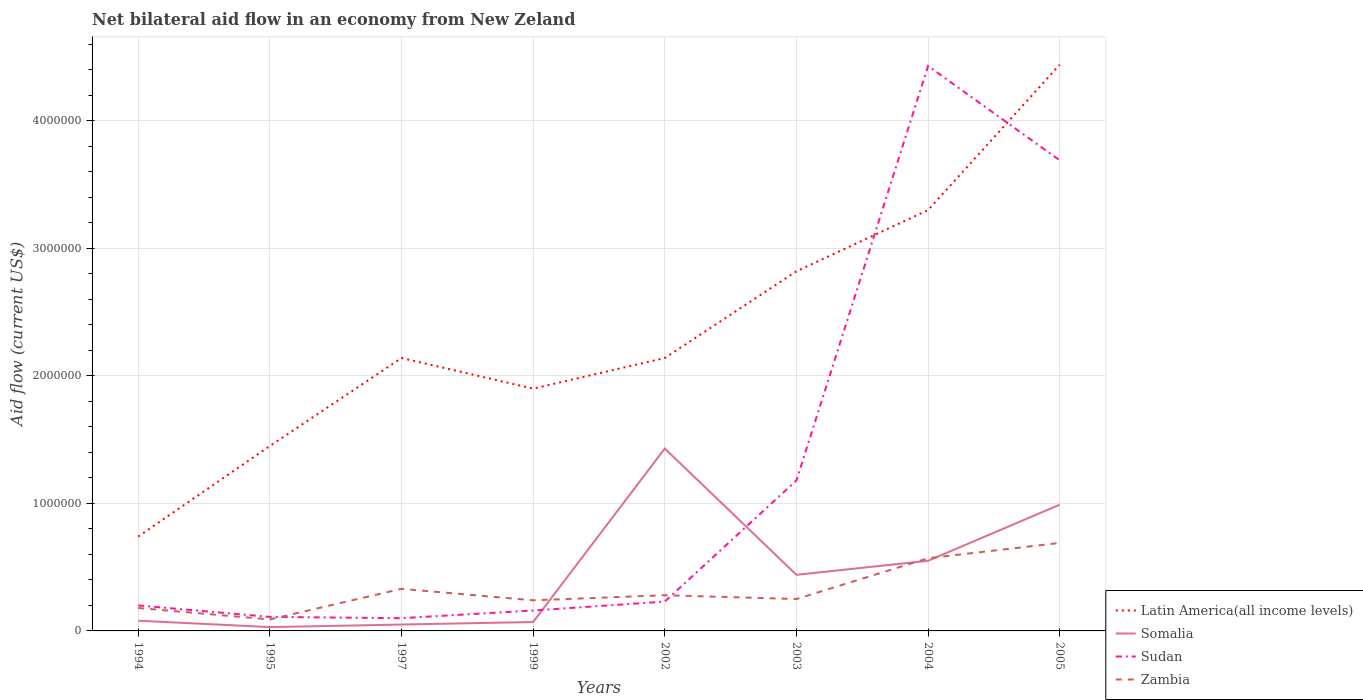How many different coloured lines are there?
Make the answer very short. 4. Does the line corresponding to Latin America(all income levels) intersect with the line corresponding to Zambia?
Keep it short and to the point. No. In which year was the net bilateral aid flow in Sudan maximum?
Provide a short and direct response. 1997. What is the difference between the highest and the second highest net bilateral aid flow in Sudan?
Provide a succinct answer. 4.33e+06. Is the net bilateral aid flow in Zambia strictly greater than the net bilateral aid flow in Latin America(all income levels) over the years?
Your answer should be very brief. Yes. How many lines are there?
Keep it short and to the point. 4. How many years are there in the graph?
Give a very brief answer. 8. Are the values on the major ticks of Y-axis written in scientific E-notation?
Give a very brief answer. No. Does the graph contain grids?
Offer a terse response. Yes. Where does the legend appear in the graph?
Give a very brief answer. Bottom right. How are the legend labels stacked?
Provide a succinct answer. Vertical. What is the title of the graph?
Make the answer very short. Net bilateral aid flow in an economy from New Zeland. What is the Aid flow (current US$) in Latin America(all income levels) in 1994?
Provide a succinct answer. 7.40e+05. What is the Aid flow (current US$) of Somalia in 1994?
Ensure brevity in your answer.  8.00e+04. What is the Aid flow (current US$) in Zambia in 1994?
Ensure brevity in your answer.  1.80e+05. What is the Aid flow (current US$) in Latin America(all income levels) in 1995?
Offer a terse response. 1.45e+06. What is the Aid flow (current US$) in Sudan in 1995?
Offer a very short reply. 1.10e+05. What is the Aid flow (current US$) in Zambia in 1995?
Your response must be concise. 9.00e+04. What is the Aid flow (current US$) of Latin America(all income levels) in 1997?
Keep it short and to the point. 2.14e+06. What is the Aid flow (current US$) of Zambia in 1997?
Give a very brief answer. 3.30e+05. What is the Aid flow (current US$) of Latin America(all income levels) in 1999?
Give a very brief answer. 1.90e+06. What is the Aid flow (current US$) in Somalia in 1999?
Give a very brief answer. 7.00e+04. What is the Aid flow (current US$) of Sudan in 1999?
Provide a short and direct response. 1.60e+05. What is the Aid flow (current US$) in Latin America(all income levels) in 2002?
Provide a short and direct response. 2.14e+06. What is the Aid flow (current US$) of Somalia in 2002?
Your answer should be compact. 1.43e+06. What is the Aid flow (current US$) of Sudan in 2002?
Your answer should be very brief. 2.30e+05. What is the Aid flow (current US$) of Zambia in 2002?
Give a very brief answer. 2.80e+05. What is the Aid flow (current US$) of Latin America(all income levels) in 2003?
Keep it short and to the point. 2.82e+06. What is the Aid flow (current US$) in Sudan in 2003?
Your answer should be very brief. 1.18e+06. What is the Aid flow (current US$) of Zambia in 2003?
Ensure brevity in your answer.  2.50e+05. What is the Aid flow (current US$) of Latin America(all income levels) in 2004?
Keep it short and to the point. 3.30e+06. What is the Aid flow (current US$) in Somalia in 2004?
Your response must be concise. 5.50e+05. What is the Aid flow (current US$) of Sudan in 2004?
Your answer should be compact. 4.43e+06. What is the Aid flow (current US$) in Zambia in 2004?
Your answer should be very brief. 5.70e+05. What is the Aid flow (current US$) in Latin America(all income levels) in 2005?
Ensure brevity in your answer.  4.44e+06. What is the Aid flow (current US$) of Somalia in 2005?
Make the answer very short. 9.90e+05. What is the Aid flow (current US$) in Sudan in 2005?
Your answer should be very brief. 3.69e+06. What is the Aid flow (current US$) in Zambia in 2005?
Ensure brevity in your answer.  6.90e+05. Across all years, what is the maximum Aid flow (current US$) of Latin America(all income levels)?
Your answer should be compact. 4.44e+06. Across all years, what is the maximum Aid flow (current US$) in Somalia?
Your response must be concise. 1.43e+06. Across all years, what is the maximum Aid flow (current US$) in Sudan?
Make the answer very short. 4.43e+06. Across all years, what is the maximum Aid flow (current US$) of Zambia?
Your answer should be compact. 6.90e+05. Across all years, what is the minimum Aid flow (current US$) of Latin America(all income levels)?
Ensure brevity in your answer.  7.40e+05. Across all years, what is the minimum Aid flow (current US$) in Sudan?
Provide a succinct answer. 1.00e+05. Across all years, what is the minimum Aid flow (current US$) in Zambia?
Your response must be concise. 9.00e+04. What is the total Aid flow (current US$) in Latin America(all income levels) in the graph?
Your answer should be very brief. 1.89e+07. What is the total Aid flow (current US$) in Somalia in the graph?
Ensure brevity in your answer.  3.64e+06. What is the total Aid flow (current US$) of Sudan in the graph?
Your answer should be very brief. 1.01e+07. What is the total Aid flow (current US$) of Zambia in the graph?
Provide a short and direct response. 2.63e+06. What is the difference between the Aid flow (current US$) in Latin America(all income levels) in 1994 and that in 1995?
Your response must be concise. -7.10e+05. What is the difference between the Aid flow (current US$) in Somalia in 1994 and that in 1995?
Provide a short and direct response. 5.00e+04. What is the difference between the Aid flow (current US$) in Sudan in 1994 and that in 1995?
Your answer should be very brief. 9.00e+04. What is the difference between the Aid flow (current US$) in Latin America(all income levels) in 1994 and that in 1997?
Provide a short and direct response. -1.40e+06. What is the difference between the Aid flow (current US$) in Sudan in 1994 and that in 1997?
Provide a short and direct response. 1.00e+05. What is the difference between the Aid flow (current US$) in Latin America(all income levels) in 1994 and that in 1999?
Give a very brief answer. -1.16e+06. What is the difference between the Aid flow (current US$) of Latin America(all income levels) in 1994 and that in 2002?
Keep it short and to the point. -1.40e+06. What is the difference between the Aid flow (current US$) of Somalia in 1994 and that in 2002?
Make the answer very short. -1.35e+06. What is the difference between the Aid flow (current US$) in Latin America(all income levels) in 1994 and that in 2003?
Keep it short and to the point. -2.08e+06. What is the difference between the Aid flow (current US$) of Somalia in 1994 and that in 2003?
Your answer should be very brief. -3.60e+05. What is the difference between the Aid flow (current US$) of Sudan in 1994 and that in 2003?
Ensure brevity in your answer.  -9.80e+05. What is the difference between the Aid flow (current US$) in Zambia in 1994 and that in 2003?
Ensure brevity in your answer.  -7.00e+04. What is the difference between the Aid flow (current US$) of Latin America(all income levels) in 1994 and that in 2004?
Your answer should be compact. -2.56e+06. What is the difference between the Aid flow (current US$) of Somalia in 1994 and that in 2004?
Your answer should be very brief. -4.70e+05. What is the difference between the Aid flow (current US$) in Sudan in 1994 and that in 2004?
Provide a short and direct response. -4.23e+06. What is the difference between the Aid flow (current US$) in Zambia in 1994 and that in 2004?
Make the answer very short. -3.90e+05. What is the difference between the Aid flow (current US$) in Latin America(all income levels) in 1994 and that in 2005?
Offer a very short reply. -3.70e+06. What is the difference between the Aid flow (current US$) in Somalia in 1994 and that in 2005?
Provide a short and direct response. -9.10e+05. What is the difference between the Aid flow (current US$) of Sudan in 1994 and that in 2005?
Make the answer very short. -3.49e+06. What is the difference between the Aid flow (current US$) of Zambia in 1994 and that in 2005?
Provide a short and direct response. -5.10e+05. What is the difference between the Aid flow (current US$) in Latin America(all income levels) in 1995 and that in 1997?
Your answer should be very brief. -6.90e+05. What is the difference between the Aid flow (current US$) in Somalia in 1995 and that in 1997?
Keep it short and to the point. -2.00e+04. What is the difference between the Aid flow (current US$) in Sudan in 1995 and that in 1997?
Give a very brief answer. 10000. What is the difference between the Aid flow (current US$) of Latin America(all income levels) in 1995 and that in 1999?
Make the answer very short. -4.50e+05. What is the difference between the Aid flow (current US$) in Zambia in 1995 and that in 1999?
Ensure brevity in your answer.  -1.50e+05. What is the difference between the Aid flow (current US$) of Latin America(all income levels) in 1995 and that in 2002?
Make the answer very short. -6.90e+05. What is the difference between the Aid flow (current US$) of Somalia in 1995 and that in 2002?
Keep it short and to the point. -1.40e+06. What is the difference between the Aid flow (current US$) in Sudan in 1995 and that in 2002?
Your answer should be very brief. -1.20e+05. What is the difference between the Aid flow (current US$) of Latin America(all income levels) in 1995 and that in 2003?
Offer a terse response. -1.37e+06. What is the difference between the Aid flow (current US$) of Somalia in 1995 and that in 2003?
Your answer should be very brief. -4.10e+05. What is the difference between the Aid flow (current US$) in Sudan in 1995 and that in 2003?
Keep it short and to the point. -1.07e+06. What is the difference between the Aid flow (current US$) in Zambia in 1995 and that in 2003?
Make the answer very short. -1.60e+05. What is the difference between the Aid flow (current US$) of Latin America(all income levels) in 1995 and that in 2004?
Make the answer very short. -1.85e+06. What is the difference between the Aid flow (current US$) of Somalia in 1995 and that in 2004?
Offer a very short reply. -5.20e+05. What is the difference between the Aid flow (current US$) in Sudan in 1995 and that in 2004?
Your answer should be compact. -4.32e+06. What is the difference between the Aid flow (current US$) of Zambia in 1995 and that in 2004?
Your response must be concise. -4.80e+05. What is the difference between the Aid flow (current US$) of Latin America(all income levels) in 1995 and that in 2005?
Provide a succinct answer. -2.99e+06. What is the difference between the Aid flow (current US$) of Somalia in 1995 and that in 2005?
Your response must be concise. -9.60e+05. What is the difference between the Aid flow (current US$) of Sudan in 1995 and that in 2005?
Keep it short and to the point. -3.58e+06. What is the difference between the Aid flow (current US$) of Zambia in 1995 and that in 2005?
Your response must be concise. -6.00e+05. What is the difference between the Aid flow (current US$) in Latin America(all income levels) in 1997 and that in 1999?
Offer a very short reply. 2.40e+05. What is the difference between the Aid flow (current US$) of Somalia in 1997 and that in 1999?
Make the answer very short. -2.00e+04. What is the difference between the Aid flow (current US$) of Sudan in 1997 and that in 1999?
Ensure brevity in your answer.  -6.00e+04. What is the difference between the Aid flow (current US$) of Latin America(all income levels) in 1997 and that in 2002?
Your response must be concise. 0. What is the difference between the Aid flow (current US$) of Somalia in 1997 and that in 2002?
Give a very brief answer. -1.38e+06. What is the difference between the Aid flow (current US$) in Latin America(all income levels) in 1997 and that in 2003?
Keep it short and to the point. -6.80e+05. What is the difference between the Aid flow (current US$) of Somalia in 1997 and that in 2003?
Your answer should be very brief. -3.90e+05. What is the difference between the Aid flow (current US$) in Sudan in 1997 and that in 2003?
Offer a very short reply. -1.08e+06. What is the difference between the Aid flow (current US$) of Zambia in 1997 and that in 2003?
Keep it short and to the point. 8.00e+04. What is the difference between the Aid flow (current US$) of Latin America(all income levels) in 1997 and that in 2004?
Provide a short and direct response. -1.16e+06. What is the difference between the Aid flow (current US$) of Somalia in 1997 and that in 2004?
Keep it short and to the point. -5.00e+05. What is the difference between the Aid flow (current US$) of Sudan in 1997 and that in 2004?
Your answer should be very brief. -4.33e+06. What is the difference between the Aid flow (current US$) in Zambia in 1997 and that in 2004?
Make the answer very short. -2.40e+05. What is the difference between the Aid flow (current US$) in Latin America(all income levels) in 1997 and that in 2005?
Give a very brief answer. -2.30e+06. What is the difference between the Aid flow (current US$) in Somalia in 1997 and that in 2005?
Provide a succinct answer. -9.40e+05. What is the difference between the Aid flow (current US$) of Sudan in 1997 and that in 2005?
Provide a short and direct response. -3.59e+06. What is the difference between the Aid flow (current US$) of Zambia in 1997 and that in 2005?
Make the answer very short. -3.60e+05. What is the difference between the Aid flow (current US$) of Somalia in 1999 and that in 2002?
Give a very brief answer. -1.36e+06. What is the difference between the Aid flow (current US$) in Sudan in 1999 and that in 2002?
Keep it short and to the point. -7.00e+04. What is the difference between the Aid flow (current US$) in Zambia in 1999 and that in 2002?
Give a very brief answer. -4.00e+04. What is the difference between the Aid flow (current US$) in Latin America(all income levels) in 1999 and that in 2003?
Provide a succinct answer. -9.20e+05. What is the difference between the Aid flow (current US$) of Somalia in 1999 and that in 2003?
Offer a terse response. -3.70e+05. What is the difference between the Aid flow (current US$) of Sudan in 1999 and that in 2003?
Ensure brevity in your answer.  -1.02e+06. What is the difference between the Aid flow (current US$) in Zambia in 1999 and that in 2003?
Give a very brief answer. -10000. What is the difference between the Aid flow (current US$) in Latin America(all income levels) in 1999 and that in 2004?
Keep it short and to the point. -1.40e+06. What is the difference between the Aid flow (current US$) of Somalia in 1999 and that in 2004?
Provide a succinct answer. -4.80e+05. What is the difference between the Aid flow (current US$) of Sudan in 1999 and that in 2004?
Make the answer very short. -4.27e+06. What is the difference between the Aid flow (current US$) of Zambia in 1999 and that in 2004?
Your response must be concise. -3.30e+05. What is the difference between the Aid flow (current US$) of Latin America(all income levels) in 1999 and that in 2005?
Ensure brevity in your answer.  -2.54e+06. What is the difference between the Aid flow (current US$) in Somalia in 1999 and that in 2005?
Offer a terse response. -9.20e+05. What is the difference between the Aid flow (current US$) of Sudan in 1999 and that in 2005?
Your response must be concise. -3.53e+06. What is the difference between the Aid flow (current US$) of Zambia in 1999 and that in 2005?
Your answer should be compact. -4.50e+05. What is the difference between the Aid flow (current US$) in Latin America(all income levels) in 2002 and that in 2003?
Your answer should be compact. -6.80e+05. What is the difference between the Aid flow (current US$) of Somalia in 2002 and that in 2003?
Make the answer very short. 9.90e+05. What is the difference between the Aid flow (current US$) in Sudan in 2002 and that in 2003?
Give a very brief answer. -9.50e+05. What is the difference between the Aid flow (current US$) in Latin America(all income levels) in 2002 and that in 2004?
Make the answer very short. -1.16e+06. What is the difference between the Aid flow (current US$) in Somalia in 2002 and that in 2004?
Offer a very short reply. 8.80e+05. What is the difference between the Aid flow (current US$) in Sudan in 2002 and that in 2004?
Provide a succinct answer. -4.20e+06. What is the difference between the Aid flow (current US$) in Zambia in 2002 and that in 2004?
Give a very brief answer. -2.90e+05. What is the difference between the Aid flow (current US$) in Latin America(all income levels) in 2002 and that in 2005?
Keep it short and to the point. -2.30e+06. What is the difference between the Aid flow (current US$) in Sudan in 2002 and that in 2005?
Your answer should be very brief. -3.46e+06. What is the difference between the Aid flow (current US$) of Zambia in 2002 and that in 2005?
Offer a very short reply. -4.10e+05. What is the difference between the Aid flow (current US$) in Latin America(all income levels) in 2003 and that in 2004?
Your answer should be compact. -4.80e+05. What is the difference between the Aid flow (current US$) in Sudan in 2003 and that in 2004?
Give a very brief answer. -3.25e+06. What is the difference between the Aid flow (current US$) in Zambia in 2003 and that in 2004?
Give a very brief answer. -3.20e+05. What is the difference between the Aid flow (current US$) in Latin America(all income levels) in 2003 and that in 2005?
Make the answer very short. -1.62e+06. What is the difference between the Aid flow (current US$) of Somalia in 2003 and that in 2005?
Provide a short and direct response. -5.50e+05. What is the difference between the Aid flow (current US$) in Sudan in 2003 and that in 2005?
Provide a succinct answer. -2.51e+06. What is the difference between the Aid flow (current US$) of Zambia in 2003 and that in 2005?
Make the answer very short. -4.40e+05. What is the difference between the Aid flow (current US$) in Latin America(all income levels) in 2004 and that in 2005?
Offer a very short reply. -1.14e+06. What is the difference between the Aid flow (current US$) of Somalia in 2004 and that in 2005?
Offer a very short reply. -4.40e+05. What is the difference between the Aid flow (current US$) of Sudan in 2004 and that in 2005?
Provide a short and direct response. 7.40e+05. What is the difference between the Aid flow (current US$) of Latin America(all income levels) in 1994 and the Aid flow (current US$) of Somalia in 1995?
Ensure brevity in your answer.  7.10e+05. What is the difference between the Aid flow (current US$) in Latin America(all income levels) in 1994 and the Aid flow (current US$) in Sudan in 1995?
Make the answer very short. 6.30e+05. What is the difference between the Aid flow (current US$) in Latin America(all income levels) in 1994 and the Aid flow (current US$) in Zambia in 1995?
Your answer should be very brief. 6.50e+05. What is the difference between the Aid flow (current US$) in Sudan in 1994 and the Aid flow (current US$) in Zambia in 1995?
Provide a short and direct response. 1.10e+05. What is the difference between the Aid flow (current US$) in Latin America(all income levels) in 1994 and the Aid flow (current US$) in Somalia in 1997?
Make the answer very short. 6.90e+05. What is the difference between the Aid flow (current US$) of Latin America(all income levels) in 1994 and the Aid flow (current US$) of Sudan in 1997?
Ensure brevity in your answer.  6.40e+05. What is the difference between the Aid flow (current US$) in Latin America(all income levels) in 1994 and the Aid flow (current US$) in Zambia in 1997?
Offer a very short reply. 4.10e+05. What is the difference between the Aid flow (current US$) of Latin America(all income levels) in 1994 and the Aid flow (current US$) of Somalia in 1999?
Ensure brevity in your answer.  6.70e+05. What is the difference between the Aid flow (current US$) in Latin America(all income levels) in 1994 and the Aid flow (current US$) in Sudan in 1999?
Offer a very short reply. 5.80e+05. What is the difference between the Aid flow (current US$) in Latin America(all income levels) in 1994 and the Aid flow (current US$) in Zambia in 1999?
Your response must be concise. 5.00e+05. What is the difference between the Aid flow (current US$) of Somalia in 1994 and the Aid flow (current US$) of Zambia in 1999?
Your answer should be compact. -1.60e+05. What is the difference between the Aid flow (current US$) in Sudan in 1994 and the Aid flow (current US$) in Zambia in 1999?
Provide a short and direct response. -4.00e+04. What is the difference between the Aid flow (current US$) in Latin America(all income levels) in 1994 and the Aid flow (current US$) in Somalia in 2002?
Offer a terse response. -6.90e+05. What is the difference between the Aid flow (current US$) of Latin America(all income levels) in 1994 and the Aid flow (current US$) of Sudan in 2002?
Give a very brief answer. 5.10e+05. What is the difference between the Aid flow (current US$) in Latin America(all income levels) in 1994 and the Aid flow (current US$) in Zambia in 2002?
Ensure brevity in your answer.  4.60e+05. What is the difference between the Aid flow (current US$) of Somalia in 1994 and the Aid flow (current US$) of Sudan in 2002?
Provide a succinct answer. -1.50e+05. What is the difference between the Aid flow (current US$) in Sudan in 1994 and the Aid flow (current US$) in Zambia in 2002?
Ensure brevity in your answer.  -8.00e+04. What is the difference between the Aid flow (current US$) in Latin America(all income levels) in 1994 and the Aid flow (current US$) in Sudan in 2003?
Offer a terse response. -4.40e+05. What is the difference between the Aid flow (current US$) of Somalia in 1994 and the Aid flow (current US$) of Sudan in 2003?
Your answer should be very brief. -1.10e+06. What is the difference between the Aid flow (current US$) of Somalia in 1994 and the Aid flow (current US$) of Zambia in 2003?
Ensure brevity in your answer.  -1.70e+05. What is the difference between the Aid flow (current US$) in Sudan in 1994 and the Aid flow (current US$) in Zambia in 2003?
Make the answer very short. -5.00e+04. What is the difference between the Aid flow (current US$) in Latin America(all income levels) in 1994 and the Aid flow (current US$) in Sudan in 2004?
Provide a succinct answer. -3.69e+06. What is the difference between the Aid flow (current US$) of Latin America(all income levels) in 1994 and the Aid flow (current US$) of Zambia in 2004?
Make the answer very short. 1.70e+05. What is the difference between the Aid flow (current US$) of Somalia in 1994 and the Aid flow (current US$) of Sudan in 2004?
Ensure brevity in your answer.  -4.35e+06. What is the difference between the Aid flow (current US$) of Somalia in 1994 and the Aid flow (current US$) of Zambia in 2004?
Your answer should be compact. -4.90e+05. What is the difference between the Aid flow (current US$) of Sudan in 1994 and the Aid flow (current US$) of Zambia in 2004?
Make the answer very short. -3.70e+05. What is the difference between the Aid flow (current US$) in Latin America(all income levels) in 1994 and the Aid flow (current US$) in Somalia in 2005?
Keep it short and to the point. -2.50e+05. What is the difference between the Aid flow (current US$) in Latin America(all income levels) in 1994 and the Aid flow (current US$) in Sudan in 2005?
Ensure brevity in your answer.  -2.95e+06. What is the difference between the Aid flow (current US$) of Latin America(all income levels) in 1994 and the Aid flow (current US$) of Zambia in 2005?
Give a very brief answer. 5.00e+04. What is the difference between the Aid flow (current US$) in Somalia in 1994 and the Aid flow (current US$) in Sudan in 2005?
Provide a short and direct response. -3.61e+06. What is the difference between the Aid flow (current US$) of Somalia in 1994 and the Aid flow (current US$) of Zambia in 2005?
Provide a short and direct response. -6.10e+05. What is the difference between the Aid flow (current US$) in Sudan in 1994 and the Aid flow (current US$) in Zambia in 2005?
Provide a succinct answer. -4.90e+05. What is the difference between the Aid flow (current US$) of Latin America(all income levels) in 1995 and the Aid flow (current US$) of Somalia in 1997?
Offer a very short reply. 1.40e+06. What is the difference between the Aid flow (current US$) in Latin America(all income levels) in 1995 and the Aid flow (current US$) in Sudan in 1997?
Your answer should be compact. 1.35e+06. What is the difference between the Aid flow (current US$) in Latin America(all income levels) in 1995 and the Aid flow (current US$) in Zambia in 1997?
Your answer should be compact. 1.12e+06. What is the difference between the Aid flow (current US$) of Somalia in 1995 and the Aid flow (current US$) of Sudan in 1997?
Give a very brief answer. -7.00e+04. What is the difference between the Aid flow (current US$) in Somalia in 1995 and the Aid flow (current US$) in Zambia in 1997?
Your response must be concise. -3.00e+05. What is the difference between the Aid flow (current US$) in Latin America(all income levels) in 1995 and the Aid flow (current US$) in Somalia in 1999?
Make the answer very short. 1.38e+06. What is the difference between the Aid flow (current US$) of Latin America(all income levels) in 1995 and the Aid flow (current US$) of Sudan in 1999?
Offer a terse response. 1.29e+06. What is the difference between the Aid flow (current US$) in Latin America(all income levels) in 1995 and the Aid flow (current US$) in Zambia in 1999?
Ensure brevity in your answer.  1.21e+06. What is the difference between the Aid flow (current US$) of Latin America(all income levels) in 1995 and the Aid flow (current US$) of Somalia in 2002?
Your answer should be compact. 2.00e+04. What is the difference between the Aid flow (current US$) of Latin America(all income levels) in 1995 and the Aid flow (current US$) of Sudan in 2002?
Offer a terse response. 1.22e+06. What is the difference between the Aid flow (current US$) in Latin America(all income levels) in 1995 and the Aid flow (current US$) in Zambia in 2002?
Give a very brief answer. 1.17e+06. What is the difference between the Aid flow (current US$) of Latin America(all income levels) in 1995 and the Aid flow (current US$) of Somalia in 2003?
Keep it short and to the point. 1.01e+06. What is the difference between the Aid flow (current US$) in Latin America(all income levels) in 1995 and the Aid flow (current US$) in Zambia in 2003?
Provide a succinct answer. 1.20e+06. What is the difference between the Aid flow (current US$) of Somalia in 1995 and the Aid flow (current US$) of Sudan in 2003?
Your answer should be compact. -1.15e+06. What is the difference between the Aid flow (current US$) in Somalia in 1995 and the Aid flow (current US$) in Zambia in 2003?
Offer a very short reply. -2.20e+05. What is the difference between the Aid flow (current US$) in Latin America(all income levels) in 1995 and the Aid flow (current US$) in Somalia in 2004?
Offer a very short reply. 9.00e+05. What is the difference between the Aid flow (current US$) of Latin America(all income levels) in 1995 and the Aid flow (current US$) of Sudan in 2004?
Provide a short and direct response. -2.98e+06. What is the difference between the Aid flow (current US$) in Latin America(all income levels) in 1995 and the Aid flow (current US$) in Zambia in 2004?
Provide a succinct answer. 8.80e+05. What is the difference between the Aid flow (current US$) in Somalia in 1995 and the Aid flow (current US$) in Sudan in 2004?
Your answer should be compact. -4.40e+06. What is the difference between the Aid flow (current US$) of Somalia in 1995 and the Aid flow (current US$) of Zambia in 2004?
Provide a succinct answer. -5.40e+05. What is the difference between the Aid flow (current US$) in Sudan in 1995 and the Aid flow (current US$) in Zambia in 2004?
Your answer should be compact. -4.60e+05. What is the difference between the Aid flow (current US$) of Latin America(all income levels) in 1995 and the Aid flow (current US$) of Sudan in 2005?
Keep it short and to the point. -2.24e+06. What is the difference between the Aid flow (current US$) of Latin America(all income levels) in 1995 and the Aid flow (current US$) of Zambia in 2005?
Keep it short and to the point. 7.60e+05. What is the difference between the Aid flow (current US$) of Somalia in 1995 and the Aid flow (current US$) of Sudan in 2005?
Provide a succinct answer. -3.66e+06. What is the difference between the Aid flow (current US$) of Somalia in 1995 and the Aid flow (current US$) of Zambia in 2005?
Offer a very short reply. -6.60e+05. What is the difference between the Aid flow (current US$) in Sudan in 1995 and the Aid flow (current US$) in Zambia in 2005?
Offer a very short reply. -5.80e+05. What is the difference between the Aid flow (current US$) in Latin America(all income levels) in 1997 and the Aid flow (current US$) in Somalia in 1999?
Provide a succinct answer. 2.07e+06. What is the difference between the Aid flow (current US$) in Latin America(all income levels) in 1997 and the Aid flow (current US$) in Sudan in 1999?
Make the answer very short. 1.98e+06. What is the difference between the Aid flow (current US$) in Latin America(all income levels) in 1997 and the Aid flow (current US$) in Zambia in 1999?
Provide a short and direct response. 1.90e+06. What is the difference between the Aid flow (current US$) in Somalia in 1997 and the Aid flow (current US$) in Sudan in 1999?
Your response must be concise. -1.10e+05. What is the difference between the Aid flow (current US$) of Somalia in 1997 and the Aid flow (current US$) of Zambia in 1999?
Your response must be concise. -1.90e+05. What is the difference between the Aid flow (current US$) of Latin America(all income levels) in 1997 and the Aid flow (current US$) of Somalia in 2002?
Your answer should be compact. 7.10e+05. What is the difference between the Aid flow (current US$) in Latin America(all income levels) in 1997 and the Aid flow (current US$) in Sudan in 2002?
Offer a terse response. 1.91e+06. What is the difference between the Aid flow (current US$) of Latin America(all income levels) in 1997 and the Aid flow (current US$) of Zambia in 2002?
Provide a short and direct response. 1.86e+06. What is the difference between the Aid flow (current US$) in Somalia in 1997 and the Aid flow (current US$) in Sudan in 2002?
Provide a succinct answer. -1.80e+05. What is the difference between the Aid flow (current US$) of Somalia in 1997 and the Aid flow (current US$) of Zambia in 2002?
Offer a terse response. -2.30e+05. What is the difference between the Aid flow (current US$) in Latin America(all income levels) in 1997 and the Aid flow (current US$) in Somalia in 2003?
Keep it short and to the point. 1.70e+06. What is the difference between the Aid flow (current US$) in Latin America(all income levels) in 1997 and the Aid flow (current US$) in Sudan in 2003?
Provide a short and direct response. 9.60e+05. What is the difference between the Aid flow (current US$) in Latin America(all income levels) in 1997 and the Aid flow (current US$) in Zambia in 2003?
Your answer should be compact. 1.89e+06. What is the difference between the Aid flow (current US$) of Somalia in 1997 and the Aid flow (current US$) of Sudan in 2003?
Offer a very short reply. -1.13e+06. What is the difference between the Aid flow (current US$) of Sudan in 1997 and the Aid flow (current US$) of Zambia in 2003?
Your answer should be compact. -1.50e+05. What is the difference between the Aid flow (current US$) of Latin America(all income levels) in 1997 and the Aid flow (current US$) of Somalia in 2004?
Keep it short and to the point. 1.59e+06. What is the difference between the Aid flow (current US$) in Latin America(all income levels) in 1997 and the Aid flow (current US$) in Sudan in 2004?
Your answer should be compact. -2.29e+06. What is the difference between the Aid flow (current US$) in Latin America(all income levels) in 1997 and the Aid flow (current US$) in Zambia in 2004?
Keep it short and to the point. 1.57e+06. What is the difference between the Aid flow (current US$) of Somalia in 1997 and the Aid flow (current US$) of Sudan in 2004?
Offer a terse response. -4.38e+06. What is the difference between the Aid flow (current US$) in Somalia in 1997 and the Aid flow (current US$) in Zambia in 2004?
Provide a short and direct response. -5.20e+05. What is the difference between the Aid flow (current US$) of Sudan in 1997 and the Aid flow (current US$) of Zambia in 2004?
Make the answer very short. -4.70e+05. What is the difference between the Aid flow (current US$) in Latin America(all income levels) in 1997 and the Aid flow (current US$) in Somalia in 2005?
Give a very brief answer. 1.15e+06. What is the difference between the Aid flow (current US$) in Latin America(all income levels) in 1997 and the Aid flow (current US$) in Sudan in 2005?
Your answer should be compact. -1.55e+06. What is the difference between the Aid flow (current US$) of Latin America(all income levels) in 1997 and the Aid flow (current US$) of Zambia in 2005?
Provide a succinct answer. 1.45e+06. What is the difference between the Aid flow (current US$) in Somalia in 1997 and the Aid flow (current US$) in Sudan in 2005?
Provide a succinct answer. -3.64e+06. What is the difference between the Aid flow (current US$) of Somalia in 1997 and the Aid flow (current US$) of Zambia in 2005?
Your response must be concise. -6.40e+05. What is the difference between the Aid flow (current US$) in Sudan in 1997 and the Aid flow (current US$) in Zambia in 2005?
Ensure brevity in your answer.  -5.90e+05. What is the difference between the Aid flow (current US$) in Latin America(all income levels) in 1999 and the Aid flow (current US$) in Sudan in 2002?
Offer a very short reply. 1.67e+06. What is the difference between the Aid flow (current US$) of Latin America(all income levels) in 1999 and the Aid flow (current US$) of Zambia in 2002?
Make the answer very short. 1.62e+06. What is the difference between the Aid flow (current US$) in Somalia in 1999 and the Aid flow (current US$) in Sudan in 2002?
Keep it short and to the point. -1.60e+05. What is the difference between the Aid flow (current US$) of Sudan in 1999 and the Aid flow (current US$) of Zambia in 2002?
Provide a short and direct response. -1.20e+05. What is the difference between the Aid flow (current US$) of Latin America(all income levels) in 1999 and the Aid flow (current US$) of Somalia in 2003?
Offer a very short reply. 1.46e+06. What is the difference between the Aid flow (current US$) of Latin America(all income levels) in 1999 and the Aid flow (current US$) of Sudan in 2003?
Give a very brief answer. 7.20e+05. What is the difference between the Aid flow (current US$) of Latin America(all income levels) in 1999 and the Aid flow (current US$) of Zambia in 2003?
Provide a succinct answer. 1.65e+06. What is the difference between the Aid flow (current US$) of Somalia in 1999 and the Aid flow (current US$) of Sudan in 2003?
Provide a short and direct response. -1.11e+06. What is the difference between the Aid flow (current US$) of Somalia in 1999 and the Aid flow (current US$) of Zambia in 2003?
Give a very brief answer. -1.80e+05. What is the difference between the Aid flow (current US$) in Sudan in 1999 and the Aid flow (current US$) in Zambia in 2003?
Give a very brief answer. -9.00e+04. What is the difference between the Aid flow (current US$) of Latin America(all income levels) in 1999 and the Aid flow (current US$) of Somalia in 2004?
Keep it short and to the point. 1.35e+06. What is the difference between the Aid flow (current US$) in Latin America(all income levels) in 1999 and the Aid flow (current US$) in Sudan in 2004?
Provide a short and direct response. -2.53e+06. What is the difference between the Aid flow (current US$) in Latin America(all income levels) in 1999 and the Aid flow (current US$) in Zambia in 2004?
Keep it short and to the point. 1.33e+06. What is the difference between the Aid flow (current US$) of Somalia in 1999 and the Aid flow (current US$) of Sudan in 2004?
Your answer should be compact. -4.36e+06. What is the difference between the Aid flow (current US$) of Somalia in 1999 and the Aid flow (current US$) of Zambia in 2004?
Ensure brevity in your answer.  -5.00e+05. What is the difference between the Aid flow (current US$) of Sudan in 1999 and the Aid flow (current US$) of Zambia in 2004?
Give a very brief answer. -4.10e+05. What is the difference between the Aid flow (current US$) of Latin America(all income levels) in 1999 and the Aid flow (current US$) of Somalia in 2005?
Ensure brevity in your answer.  9.10e+05. What is the difference between the Aid flow (current US$) in Latin America(all income levels) in 1999 and the Aid flow (current US$) in Sudan in 2005?
Make the answer very short. -1.79e+06. What is the difference between the Aid flow (current US$) of Latin America(all income levels) in 1999 and the Aid flow (current US$) of Zambia in 2005?
Ensure brevity in your answer.  1.21e+06. What is the difference between the Aid flow (current US$) of Somalia in 1999 and the Aid flow (current US$) of Sudan in 2005?
Give a very brief answer. -3.62e+06. What is the difference between the Aid flow (current US$) of Somalia in 1999 and the Aid flow (current US$) of Zambia in 2005?
Your response must be concise. -6.20e+05. What is the difference between the Aid flow (current US$) in Sudan in 1999 and the Aid flow (current US$) in Zambia in 2005?
Ensure brevity in your answer.  -5.30e+05. What is the difference between the Aid flow (current US$) in Latin America(all income levels) in 2002 and the Aid flow (current US$) in Somalia in 2003?
Offer a very short reply. 1.70e+06. What is the difference between the Aid flow (current US$) of Latin America(all income levels) in 2002 and the Aid flow (current US$) of Sudan in 2003?
Give a very brief answer. 9.60e+05. What is the difference between the Aid flow (current US$) of Latin America(all income levels) in 2002 and the Aid flow (current US$) of Zambia in 2003?
Provide a short and direct response. 1.89e+06. What is the difference between the Aid flow (current US$) of Somalia in 2002 and the Aid flow (current US$) of Sudan in 2003?
Provide a succinct answer. 2.50e+05. What is the difference between the Aid flow (current US$) of Somalia in 2002 and the Aid flow (current US$) of Zambia in 2003?
Your answer should be very brief. 1.18e+06. What is the difference between the Aid flow (current US$) of Latin America(all income levels) in 2002 and the Aid flow (current US$) of Somalia in 2004?
Keep it short and to the point. 1.59e+06. What is the difference between the Aid flow (current US$) in Latin America(all income levels) in 2002 and the Aid flow (current US$) in Sudan in 2004?
Offer a terse response. -2.29e+06. What is the difference between the Aid flow (current US$) of Latin America(all income levels) in 2002 and the Aid flow (current US$) of Zambia in 2004?
Make the answer very short. 1.57e+06. What is the difference between the Aid flow (current US$) of Somalia in 2002 and the Aid flow (current US$) of Sudan in 2004?
Provide a succinct answer. -3.00e+06. What is the difference between the Aid flow (current US$) in Somalia in 2002 and the Aid flow (current US$) in Zambia in 2004?
Make the answer very short. 8.60e+05. What is the difference between the Aid flow (current US$) of Latin America(all income levels) in 2002 and the Aid flow (current US$) of Somalia in 2005?
Ensure brevity in your answer.  1.15e+06. What is the difference between the Aid flow (current US$) in Latin America(all income levels) in 2002 and the Aid flow (current US$) in Sudan in 2005?
Offer a very short reply. -1.55e+06. What is the difference between the Aid flow (current US$) of Latin America(all income levels) in 2002 and the Aid flow (current US$) of Zambia in 2005?
Your answer should be very brief. 1.45e+06. What is the difference between the Aid flow (current US$) in Somalia in 2002 and the Aid flow (current US$) in Sudan in 2005?
Keep it short and to the point. -2.26e+06. What is the difference between the Aid flow (current US$) in Somalia in 2002 and the Aid flow (current US$) in Zambia in 2005?
Offer a very short reply. 7.40e+05. What is the difference between the Aid flow (current US$) in Sudan in 2002 and the Aid flow (current US$) in Zambia in 2005?
Offer a very short reply. -4.60e+05. What is the difference between the Aid flow (current US$) of Latin America(all income levels) in 2003 and the Aid flow (current US$) of Somalia in 2004?
Your response must be concise. 2.27e+06. What is the difference between the Aid flow (current US$) in Latin America(all income levels) in 2003 and the Aid flow (current US$) in Sudan in 2004?
Keep it short and to the point. -1.61e+06. What is the difference between the Aid flow (current US$) in Latin America(all income levels) in 2003 and the Aid flow (current US$) in Zambia in 2004?
Provide a succinct answer. 2.25e+06. What is the difference between the Aid flow (current US$) in Somalia in 2003 and the Aid flow (current US$) in Sudan in 2004?
Ensure brevity in your answer.  -3.99e+06. What is the difference between the Aid flow (current US$) of Somalia in 2003 and the Aid flow (current US$) of Zambia in 2004?
Offer a very short reply. -1.30e+05. What is the difference between the Aid flow (current US$) in Latin America(all income levels) in 2003 and the Aid flow (current US$) in Somalia in 2005?
Offer a terse response. 1.83e+06. What is the difference between the Aid flow (current US$) in Latin America(all income levels) in 2003 and the Aid flow (current US$) in Sudan in 2005?
Ensure brevity in your answer.  -8.70e+05. What is the difference between the Aid flow (current US$) in Latin America(all income levels) in 2003 and the Aid flow (current US$) in Zambia in 2005?
Your answer should be very brief. 2.13e+06. What is the difference between the Aid flow (current US$) of Somalia in 2003 and the Aid flow (current US$) of Sudan in 2005?
Provide a short and direct response. -3.25e+06. What is the difference between the Aid flow (current US$) of Sudan in 2003 and the Aid flow (current US$) of Zambia in 2005?
Offer a terse response. 4.90e+05. What is the difference between the Aid flow (current US$) of Latin America(all income levels) in 2004 and the Aid flow (current US$) of Somalia in 2005?
Keep it short and to the point. 2.31e+06. What is the difference between the Aid flow (current US$) in Latin America(all income levels) in 2004 and the Aid flow (current US$) in Sudan in 2005?
Keep it short and to the point. -3.90e+05. What is the difference between the Aid flow (current US$) in Latin America(all income levels) in 2004 and the Aid flow (current US$) in Zambia in 2005?
Ensure brevity in your answer.  2.61e+06. What is the difference between the Aid flow (current US$) of Somalia in 2004 and the Aid flow (current US$) of Sudan in 2005?
Offer a terse response. -3.14e+06. What is the difference between the Aid flow (current US$) in Somalia in 2004 and the Aid flow (current US$) in Zambia in 2005?
Offer a very short reply. -1.40e+05. What is the difference between the Aid flow (current US$) in Sudan in 2004 and the Aid flow (current US$) in Zambia in 2005?
Your answer should be compact. 3.74e+06. What is the average Aid flow (current US$) of Latin America(all income levels) per year?
Make the answer very short. 2.37e+06. What is the average Aid flow (current US$) of Somalia per year?
Your response must be concise. 4.55e+05. What is the average Aid flow (current US$) in Sudan per year?
Your answer should be compact. 1.26e+06. What is the average Aid flow (current US$) of Zambia per year?
Your answer should be very brief. 3.29e+05. In the year 1994, what is the difference between the Aid flow (current US$) in Latin America(all income levels) and Aid flow (current US$) in Sudan?
Offer a very short reply. 5.40e+05. In the year 1994, what is the difference between the Aid flow (current US$) in Latin America(all income levels) and Aid flow (current US$) in Zambia?
Give a very brief answer. 5.60e+05. In the year 1994, what is the difference between the Aid flow (current US$) in Somalia and Aid flow (current US$) in Sudan?
Your response must be concise. -1.20e+05. In the year 1994, what is the difference between the Aid flow (current US$) of Somalia and Aid flow (current US$) of Zambia?
Your answer should be very brief. -1.00e+05. In the year 1995, what is the difference between the Aid flow (current US$) of Latin America(all income levels) and Aid flow (current US$) of Somalia?
Make the answer very short. 1.42e+06. In the year 1995, what is the difference between the Aid flow (current US$) in Latin America(all income levels) and Aid flow (current US$) in Sudan?
Keep it short and to the point. 1.34e+06. In the year 1995, what is the difference between the Aid flow (current US$) of Latin America(all income levels) and Aid flow (current US$) of Zambia?
Your response must be concise. 1.36e+06. In the year 1997, what is the difference between the Aid flow (current US$) of Latin America(all income levels) and Aid flow (current US$) of Somalia?
Offer a terse response. 2.09e+06. In the year 1997, what is the difference between the Aid flow (current US$) of Latin America(all income levels) and Aid flow (current US$) of Sudan?
Ensure brevity in your answer.  2.04e+06. In the year 1997, what is the difference between the Aid flow (current US$) of Latin America(all income levels) and Aid flow (current US$) of Zambia?
Offer a terse response. 1.81e+06. In the year 1997, what is the difference between the Aid flow (current US$) of Somalia and Aid flow (current US$) of Zambia?
Your answer should be very brief. -2.80e+05. In the year 1999, what is the difference between the Aid flow (current US$) of Latin America(all income levels) and Aid flow (current US$) of Somalia?
Provide a short and direct response. 1.83e+06. In the year 1999, what is the difference between the Aid flow (current US$) of Latin America(all income levels) and Aid flow (current US$) of Sudan?
Offer a very short reply. 1.74e+06. In the year 1999, what is the difference between the Aid flow (current US$) in Latin America(all income levels) and Aid flow (current US$) in Zambia?
Keep it short and to the point. 1.66e+06. In the year 1999, what is the difference between the Aid flow (current US$) of Somalia and Aid flow (current US$) of Sudan?
Your answer should be compact. -9.00e+04. In the year 1999, what is the difference between the Aid flow (current US$) of Somalia and Aid flow (current US$) of Zambia?
Give a very brief answer. -1.70e+05. In the year 2002, what is the difference between the Aid flow (current US$) of Latin America(all income levels) and Aid flow (current US$) of Somalia?
Provide a succinct answer. 7.10e+05. In the year 2002, what is the difference between the Aid flow (current US$) in Latin America(all income levels) and Aid flow (current US$) in Sudan?
Provide a short and direct response. 1.91e+06. In the year 2002, what is the difference between the Aid flow (current US$) in Latin America(all income levels) and Aid flow (current US$) in Zambia?
Make the answer very short. 1.86e+06. In the year 2002, what is the difference between the Aid flow (current US$) of Somalia and Aid flow (current US$) of Sudan?
Make the answer very short. 1.20e+06. In the year 2002, what is the difference between the Aid flow (current US$) of Somalia and Aid flow (current US$) of Zambia?
Keep it short and to the point. 1.15e+06. In the year 2003, what is the difference between the Aid flow (current US$) of Latin America(all income levels) and Aid flow (current US$) of Somalia?
Your answer should be very brief. 2.38e+06. In the year 2003, what is the difference between the Aid flow (current US$) in Latin America(all income levels) and Aid flow (current US$) in Sudan?
Your answer should be compact. 1.64e+06. In the year 2003, what is the difference between the Aid flow (current US$) in Latin America(all income levels) and Aid flow (current US$) in Zambia?
Make the answer very short. 2.57e+06. In the year 2003, what is the difference between the Aid flow (current US$) of Somalia and Aid flow (current US$) of Sudan?
Offer a very short reply. -7.40e+05. In the year 2003, what is the difference between the Aid flow (current US$) in Sudan and Aid flow (current US$) in Zambia?
Your answer should be very brief. 9.30e+05. In the year 2004, what is the difference between the Aid flow (current US$) of Latin America(all income levels) and Aid flow (current US$) of Somalia?
Make the answer very short. 2.75e+06. In the year 2004, what is the difference between the Aid flow (current US$) of Latin America(all income levels) and Aid flow (current US$) of Sudan?
Offer a very short reply. -1.13e+06. In the year 2004, what is the difference between the Aid flow (current US$) in Latin America(all income levels) and Aid flow (current US$) in Zambia?
Provide a succinct answer. 2.73e+06. In the year 2004, what is the difference between the Aid flow (current US$) of Somalia and Aid flow (current US$) of Sudan?
Provide a short and direct response. -3.88e+06. In the year 2004, what is the difference between the Aid flow (current US$) in Somalia and Aid flow (current US$) in Zambia?
Your answer should be compact. -2.00e+04. In the year 2004, what is the difference between the Aid flow (current US$) of Sudan and Aid flow (current US$) of Zambia?
Ensure brevity in your answer.  3.86e+06. In the year 2005, what is the difference between the Aid flow (current US$) of Latin America(all income levels) and Aid flow (current US$) of Somalia?
Provide a succinct answer. 3.45e+06. In the year 2005, what is the difference between the Aid flow (current US$) of Latin America(all income levels) and Aid flow (current US$) of Sudan?
Your answer should be compact. 7.50e+05. In the year 2005, what is the difference between the Aid flow (current US$) in Latin America(all income levels) and Aid flow (current US$) in Zambia?
Make the answer very short. 3.75e+06. In the year 2005, what is the difference between the Aid flow (current US$) in Somalia and Aid flow (current US$) in Sudan?
Keep it short and to the point. -2.70e+06. In the year 2005, what is the difference between the Aid flow (current US$) of Sudan and Aid flow (current US$) of Zambia?
Provide a short and direct response. 3.00e+06. What is the ratio of the Aid flow (current US$) in Latin America(all income levels) in 1994 to that in 1995?
Give a very brief answer. 0.51. What is the ratio of the Aid flow (current US$) in Somalia in 1994 to that in 1995?
Offer a terse response. 2.67. What is the ratio of the Aid flow (current US$) in Sudan in 1994 to that in 1995?
Offer a very short reply. 1.82. What is the ratio of the Aid flow (current US$) in Zambia in 1994 to that in 1995?
Keep it short and to the point. 2. What is the ratio of the Aid flow (current US$) in Latin America(all income levels) in 1994 to that in 1997?
Ensure brevity in your answer.  0.35. What is the ratio of the Aid flow (current US$) of Sudan in 1994 to that in 1997?
Make the answer very short. 2. What is the ratio of the Aid flow (current US$) of Zambia in 1994 to that in 1997?
Give a very brief answer. 0.55. What is the ratio of the Aid flow (current US$) in Latin America(all income levels) in 1994 to that in 1999?
Give a very brief answer. 0.39. What is the ratio of the Aid flow (current US$) of Latin America(all income levels) in 1994 to that in 2002?
Your answer should be very brief. 0.35. What is the ratio of the Aid flow (current US$) of Somalia in 1994 to that in 2002?
Ensure brevity in your answer.  0.06. What is the ratio of the Aid flow (current US$) in Sudan in 1994 to that in 2002?
Your answer should be compact. 0.87. What is the ratio of the Aid flow (current US$) of Zambia in 1994 to that in 2002?
Keep it short and to the point. 0.64. What is the ratio of the Aid flow (current US$) of Latin America(all income levels) in 1994 to that in 2003?
Provide a succinct answer. 0.26. What is the ratio of the Aid flow (current US$) of Somalia in 1994 to that in 2003?
Your response must be concise. 0.18. What is the ratio of the Aid flow (current US$) of Sudan in 1994 to that in 2003?
Give a very brief answer. 0.17. What is the ratio of the Aid flow (current US$) of Zambia in 1994 to that in 2003?
Offer a very short reply. 0.72. What is the ratio of the Aid flow (current US$) of Latin America(all income levels) in 1994 to that in 2004?
Provide a succinct answer. 0.22. What is the ratio of the Aid flow (current US$) in Somalia in 1994 to that in 2004?
Provide a succinct answer. 0.15. What is the ratio of the Aid flow (current US$) in Sudan in 1994 to that in 2004?
Ensure brevity in your answer.  0.05. What is the ratio of the Aid flow (current US$) in Zambia in 1994 to that in 2004?
Make the answer very short. 0.32. What is the ratio of the Aid flow (current US$) in Somalia in 1994 to that in 2005?
Your answer should be compact. 0.08. What is the ratio of the Aid flow (current US$) in Sudan in 1994 to that in 2005?
Give a very brief answer. 0.05. What is the ratio of the Aid flow (current US$) in Zambia in 1994 to that in 2005?
Your answer should be compact. 0.26. What is the ratio of the Aid flow (current US$) of Latin America(all income levels) in 1995 to that in 1997?
Provide a short and direct response. 0.68. What is the ratio of the Aid flow (current US$) of Somalia in 1995 to that in 1997?
Ensure brevity in your answer.  0.6. What is the ratio of the Aid flow (current US$) in Sudan in 1995 to that in 1997?
Keep it short and to the point. 1.1. What is the ratio of the Aid flow (current US$) in Zambia in 1995 to that in 1997?
Your answer should be compact. 0.27. What is the ratio of the Aid flow (current US$) in Latin America(all income levels) in 1995 to that in 1999?
Keep it short and to the point. 0.76. What is the ratio of the Aid flow (current US$) of Somalia in 1995 to that in 1999?
Your response must be concise. 0.43. What is the ratio of the Aid flow (current US$) in Sudan in 1995 to that in 1999?
Ensure brevity in your answer.  0.69. What is the ratio of the Aid flow (current US$) in Latin America(all income levels) in 1995 to that in 2002?
Your answer should be very brief. 0.68. What is the ratio of the Aid flow (current US$) of Somalia in 1995 to that in 2002?
Your response must be concise. 0.02. What is the ratio of the Aid flow (current US$) of Sudan in 1995 to that in 2002?
Your answer should be compact. 0.48. What is the ratio of the Aid flow (current US$) in Zambia in 1995 to that in 2002?
Provide a short and direct response. 0.32. What is the ratio of the Aid flow (current US$) of Latin America(all income levels) in 1995 to that in 2003?
Provide a succinct answer. 0.51. What is the ratio of the Aid flow (current US$) of Somalia in 1995 to that in 2003?
Keep it short and to the point. 0.07. What is the ratio of the Aid flow (current US$) in Sudan in 1995 to that in 2003?
Provide a succinct answer. 0.09. What is the ratio of the Aid flow (current US$) of Zambia in 1995 to that in 2003?
Ensure brevity in your answer.  0.36. What is the ratio of the Aid flow (current US$) of Latin America(all income levels) in 1995 to that in 2004?
Your answer should be very brief. 0.44. What is the ratio of the Aid flow (current US$) in Somalia in 1995 to that in 2004?
Ensure brevity in your answer.  0.05. What is the ratio of the Aid flow (current US$) in Sudan in 1995 to that in 2004?
Provide a short and direct response. 0.02. What is the ratio of the Aid flow (current US$) in Zambia in 1995 to that in 2004?
Provide a short and direct response. 0.16. What is the ratio of the Aid flow (current US$) in Latin America(all income levels) in 1995 to that in 2005?
Your response must be concise. 0.33. What is the ratio of the Aid flow (current US$) of Somalia in 1995 to that in 2005?
Ensure brevity in your answer.  0.03. What is the ratio of the Aid flow (current US$) in Sudan in 1995 to that in 2005?
Offer a very short reply. 0.03. What is the ratio of the Aid flow (current US$) in Zambia in 1995 to that in 2005?
Your answer should be very brief. 0.13. What is the ratio of the Aid flow (current US$) in Latin America(all income levels) in 1997 to that in 1999?
Offer a very short reply. 1.13. What is the ratio of the Aid flow (current US$) of Somalia in 1997 to that in 1999?
Ensure brevity in your answer.  0.71. What is the ratio of the Aid flow (current US$) in Sudan in 1997 to that in 1999?
Ensure brevity in your answer.  0.62. What is the ratio of the Aid flow (current US$) in Zambia in 1997 to that in 1999?
Your response must be concise. 1.38. What is the ratio of the Aid flow (current US$) of Somalia in 1997 to that in 2002?
Provide a short and direct response. 0.04. What is the ratio of the Aid flow (current US$) of Sudan in 1997 to that in 2002?
Make the answer very short. 0.43. What is the ratio of the Aid flow (current US$) in Zambia in 1997 to that in 2002?
Make the answer very short. 1.18. What is the ratio of the Aid flow (current US$) in Latin America(all income levels) in 1997 to that in 2003?
Provide a succinct answer. 0.76. What is the ratio of the Aid flow (current US$) in Somalia in 1997 to that in 2003?
Your answer should be very brief. 0.11. What is the ratio of the Aid flow (current US$) of Sudan in 1997 to that in 2003?
Ensure brevity in your answer.  0.08. What is the ratio of the Aid flow (current US$) in Zambia in 1997 to that in 2003?
Offer a terse response. 1.32. What is the ratio of the Aid flow (current US$) of Latin America(all income levels) in 1997 to that in 2004?
Your answer should be very brief. 0.65. What is the ratio of the Aid flow (current US$) in Somalia in 1997 to that in 2004?
Offer a terse response. 0.09. What is the ratio of the Aid flow (current US$) of Sudan in 1997 to that in 2004?
Give a very brief answer. 0.02. What is the ratio of the Aid flow (current US$) in Zambia in 1997 to that in 2004?
Offer a terse response. 0.58. What is the ratio of the Aid flow (current US$) in Latin America(all income levels) in 1997 to that in 2005?
Provide a succinct answer. 0.48. What is the ratio of the Aid flow (current US$) of Somalia in 1997 to that in 2005?
Keep it short and to the point. 0.05. What is the ratio of the Aid flow (current US$) in Sudan in 1997 to that in 2005?
Provide a short and direct response. 0.03. What is the ratio of the Aid flow (current US$) in Zambia in 1997 to that in 2005?
Make the answer very short. 0.48. What is the ratio of the Aid flow (current US$) of Latin America(all income levels) in 1999 to that in 2002?
Your answer should be compact. 0.89. What is the ratio of the Aid flow (current US$) in Somalia in 1999 to that in 2002?
Your answer should be compact. 0.05. What is the ratio of the Aid flow (current US$) of Sudan in 1999 to that in 2002?
Ensure brevity in your answer.  0.7. What is the ratio of the Aid flow (current US$) in Zambia in 1999 to that in 2002?
Provide a succinct answer. 0.86. What is the ratio of the Aid flow (current US$) of Latin America(all income levels) in 1999 to that in 2003?
Give a very brief answer. 0.67. What is the ratio of the Aid flow (current US$) in Somalia in 1999 to that in 2003?
Your answer should be very brief. 0.16. What is the ratio of the Aid flow (current US$) in Sudan in 1999 to that in 2003?
Offer a terse response. 0.14. What is the ratio of the Aid flow (current US$) in Zambia in 1999 to that in 2003?
Provide a short and direct response. 0.96. What is the ratio of the Aid flow (current US$) of Latin America(all income levels) in 1999 to that in 2004?
Your answer should be compact. 0.58. What is the ratio of the Aid flow (current US$) in Somalia in 1999 to that in 2004?
Provide a short and direct response. 0.13. What is the ratio of the Aid flow (current US$) in Sudan in 1999 to that in 2004?
Your answer should be compact. 0.04. What is the ratio of the Aid flow (current US$) in Zambia in 1999 to that in 2004?
Ensure brevity in your answer.  0.42. What is the ratio of the Aid flow (current US$) of Latin America(all income levels) in 1999 to that in 2005?
Give a very brief answer. 0.43. What is the ratio of the Aid flow (current US$) in Somalia in 1999 to that in 2005?
Give a very brief answer. 0.07. What is the ratio of the Aid flow (current US$) of Sudan in 1999 to that in 2005?
Provide a succinct answer. 0.04. What is the ratio of the Aid flow (current US$) in Zambia in 1999 to that in 2005?
Your answer should be very brief. 0.35. What is the ratio of the Aid flow (current US$) of Latin America(all income levels) in 2002 to that in 2003?
Provide a short and direct response. 0.76. What is the ratio of the Aid flow (current US$) of Sudan in 2002 to that in 2003?
Offer a very short reply. 0.19. What is the ratio of the Aid flow (current US$) of Zambia in 2002 to that in 2003?
Make the answer very short. 1.12. What is the ratio of the Aid flow (current US$) in Latin America(all income levels) in 2002 to that in 2004?
Offer a very short reply. 0.65. What is the ratio of the Aid flow (current US$) in Sudan in 2002 to that in 2004?
Provide a succinct answer. 0.05. What is the ratio of the Aid flow (current US$) in Zambia in 2002 to that in 2004?
Give a very brief answer. 0.49. What is the ratio of the Aid flow (current US$) of Latin America(all income levels) in 2002 to that in 2005?
Provide a short and direct response. 0.48. What is the ratio of the Aid flow (current US$) of Somalia in 2002 to that in 2005?
Offer a very short reply. 1.44. What is the ratio of the Aid flow (current US$) in Sudan in 2002 to that in 2005?
Give a very brief answer. 0.06. What is the ratio of the Aid flow (current US$) of Zambia in 2002 to that in 2005?
Ensure brevity in your answer.  0.41. What is the ratio of the Aid flow (current US$) of Latin America(all income levels) in 2003 to that in 2004?
Your answer should be very brief. 0.85. What is the ratio of the Aid flow (current US$) of Somalia in 2003 to that in 2004?
Your response must be concise. 0.8. What is the ratio of the Aid flow (current US$) of Sudan in 2003 to that in 2004?
Your response must be concise. 0.27. What is the ratio of the Aid flow (current US$) in Zambia in 2003 to that in 2004?
Keep it short and to the point. 0.44. What is the ratio of the Aid flow (current US$) in Latin America(all income levels) in 2003 to that in 2005?
Your answer should be very brief. 0.64. What is the ratio of the Aid flow (current US$) in Somalia in 2003 to that in 2005?
Provide a succinct answer. 0.44. What is the ratio of the Aid flow (current US$) in Sudan in 2003 to that in 2005?
Your response must be concise. 0.32. What is the ratio of the Aid flow (current US$) of Zambia in 2003 to that in 2005?
Keep it short and to the point. 0.36. What is the ratio of the Aid flow (current US$) in Latin America(all income levels) in 2004 to that in 2005?
Keep it short and to the point. 0.74. What is the ratio of the Aid flow (current US$) in Somalia in 2004 to that in 2005?
Ensure brevity in your answer.  0.56. What is the ratio of the Aid flow (current US$) of Sudan in 2004 to that in 2005?
Ensure brevity in your answer.  1.2. What is the ratio of the Aid flow (current US$) of Zambia in 2004 to that in 2005?
Give a very brief answer. 0.83. What is the difference between the highest and the second highest Aid flow (current US$) in Latin America(all income levels)?
Keep it short and to the point. 1.14e+06. What is the difference between the highest and the second highest Aid flow (current US$) in Somalia?
Your response must be concise. 4.40e+05. What is the difference between the highest and the second highest Aid flow (current US$) in Sudan?
Your answer should be very brief. 7.40e+05. What is the difference between the highest and the second highest Aid flow (current US$) in Zambia?
Keep it short and to the point. 1.20e+05. What is the difference between the highest and the lowest Aid flow (current US$) of Latin America(all income levels)?
Offer a very short reply. 3.70e+06. What is the difference between the highest and the lowest Aid flow (current US$) of Somalia?
Give a very brief answer. 1.40e+06. What is the difference between the highest and the lowest Aid flow (current US$) in Sudan?
Ensure brevity in your answer.  4.33e+06. 